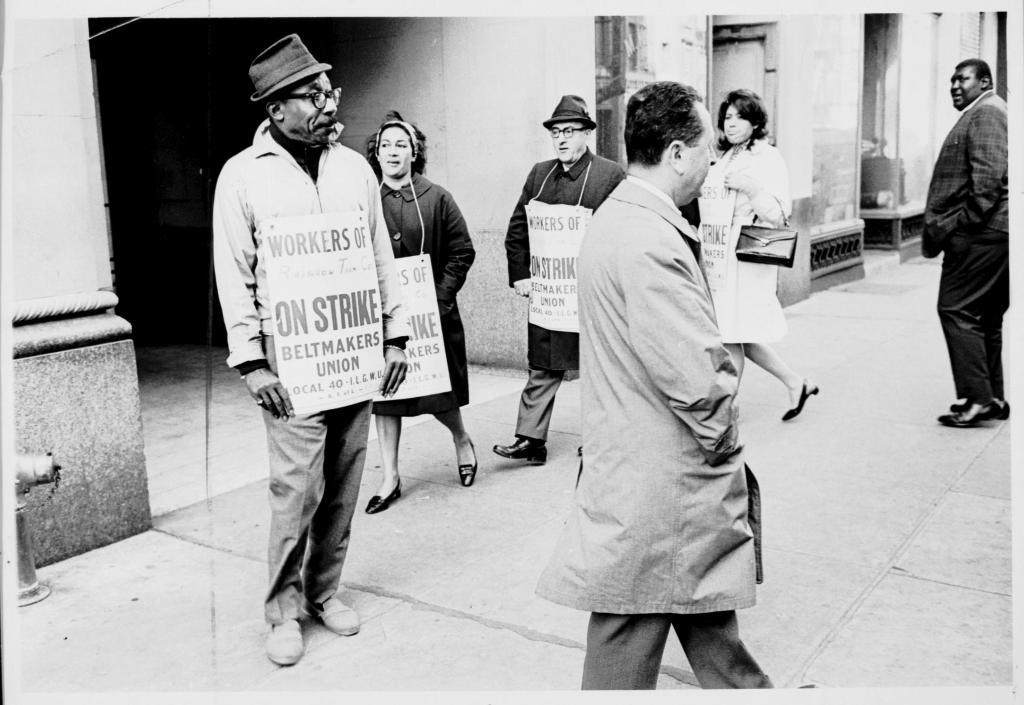What are the people in the center of the image doing? The people in the center of the image are holding banners. What can be seen in the background of the image? There is a building, a wall, a window, and a pole in the background of the image. Can you describe any other objects in the background of the image? There are other unspecified objects in the background of the image. What type of wine is being served at the event in the image? There is no indication of an event or wine being served in the image. Can you solve the riddle written on the banner in the image? There is no riddle visible on the banners in the image. 